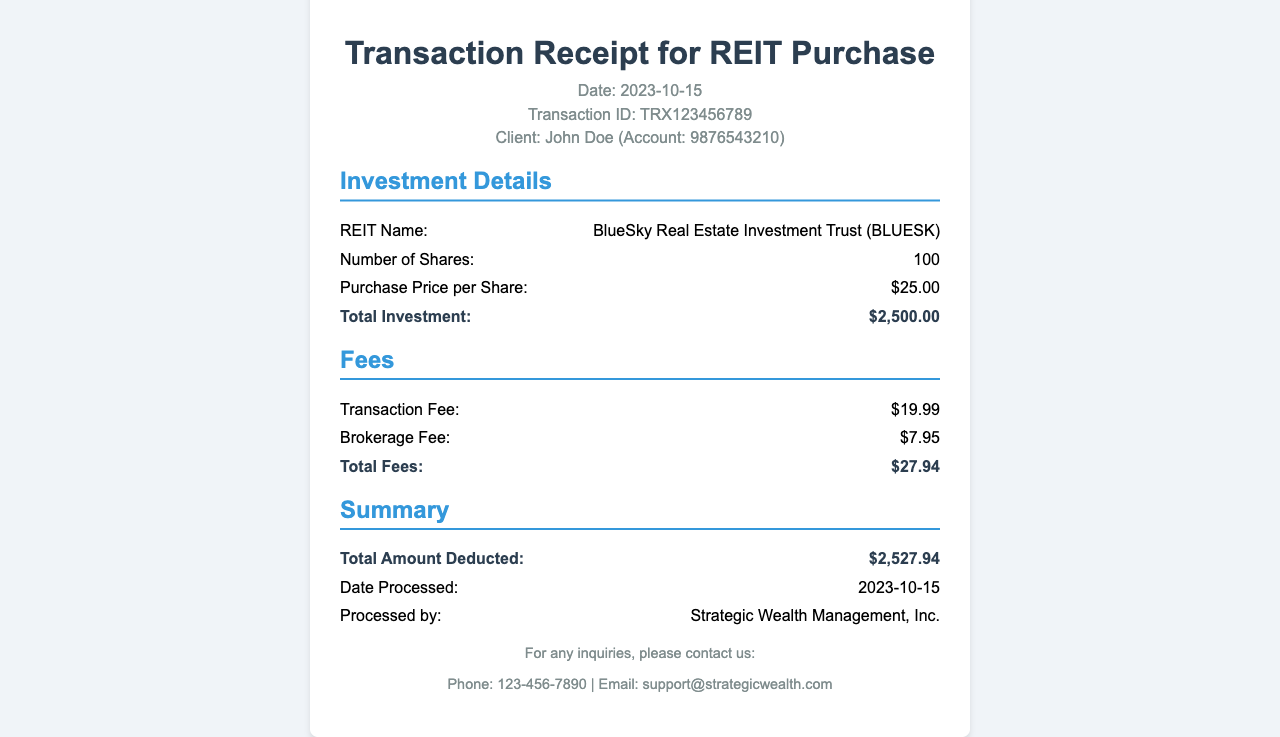What is the date of the transaction? The date of the transaction is found in the header section, which states "Date: 2023-10-15".
Answer: 2023-10-15 What is the client's name? The client's name is mentioned in the header section where it states "Client: John Doe".
Answer: John Doe How many shares were purchased? The number of shares is detailed in the investment section, where it states "Number of Shares: 100".
Answer: 100 What is the purchase price per share? The purchase price per share is indicated in the investment section as "Purchase Price per Share: $25.00".
Answer: $25.00 What is the total investment amount? The total investment is calculated and stated in the investment section as "Total Investment: $2,500.00".
Answer: $2,500.00 What are the total fees charged? The total fees are mentioned in the fees section, shown as "Total Fees: $27.94".
Answer: $27.94 What is the total amount deducted? The total amount deducted is found in the summary section as "Total Amount Deducted: $2,527.94".
Answer: $2,527.94 Who processed the transaction? The name of the processing entity is mentioned in the summary section, stating "Processed by: Strategic Wealth Management, Inc.".
Answer: Strategic Wealth Management, Inc 